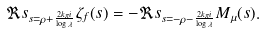<formula> <loc_0><loc_0><loc_500><loc_500>\Re s _ { s = \rho + \frac { 2 k \pi i } { \log \lambda } } \zeta _ { f } ( s ) = - \Re s _ { s = - \rho - \frac { 2 k \pi i } { \log \lambda } } M _ { \mu } ( s ) .</formula> 